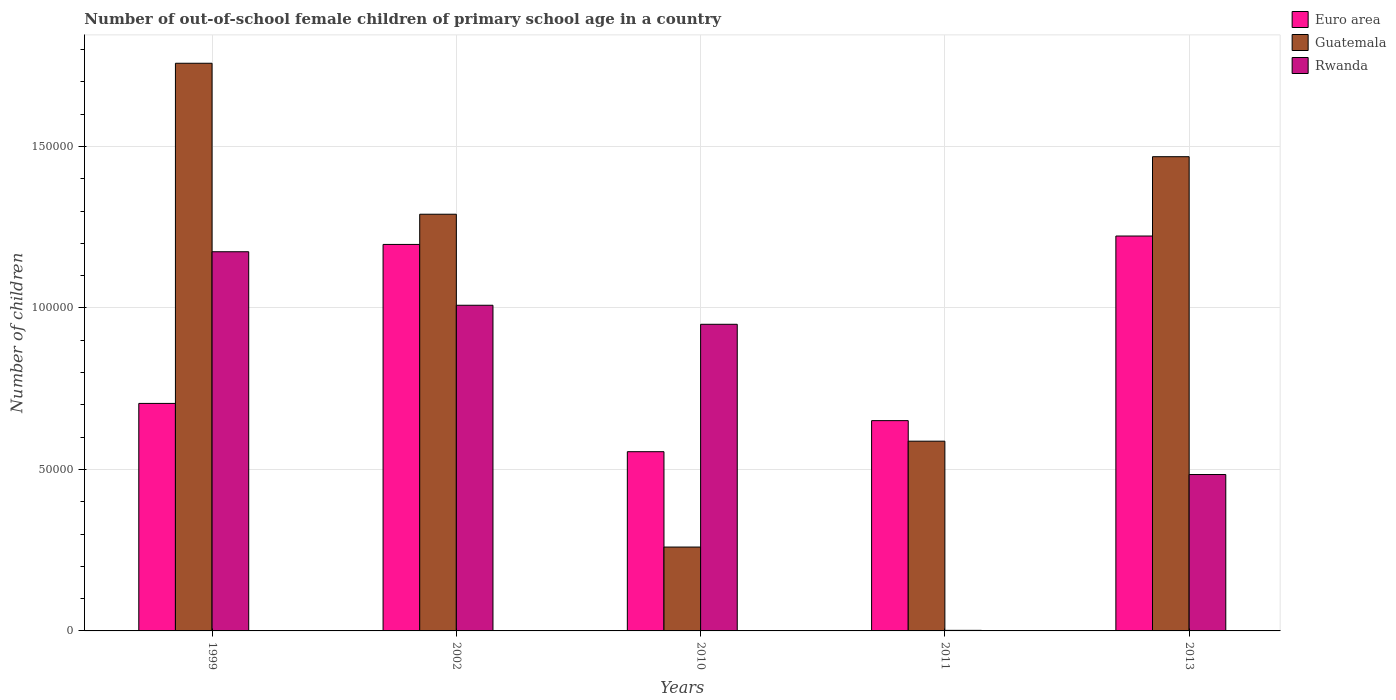How many different coloured bars are there?
Provide a succinct answer. 3. How many bars are there on the 2nd tick from the right?
Give a very brief answer. 3. What is the number of out-of-school female children in Rwanda in 1999?
Your answer should be compact. 1.17e+05. Across all years, what is the maximum number of out-of-school female children in Rwanda?
Keep it short and to the point. 1.17e+05. Across all years, what is the minimum number of out-of-school female children in Euro area?
Provide a succinct answer. 5.55e+04. What is the total number of out-of-school female children in Guatemala in the graph?
Keep it short and to the point. 5.36e+05. What is the difference between the number of out-of-school female children in Rwanda in 2010 and that in 2011?
Provide a short and direct response. 9.48e+04. What is the difference between the number of out-of-school female children in Guatemala in 2010 and the number of out-of-school female children in Euro area in 1999?
Ensure brevity in your answer.  -4.45e+04. What is the average number of out-of-school female children in Guatemala per year?
Your answer should be compact. 1.07e+05. In the year 2013, what is the difference between the number of out-of-school female children in Guatemala and number of out-of-school female children in Rwanda?
Provide a short and direct response. 9.84e+04. What is the ratio of the number of out-of-school female children in Rwanda in 2002 to that in 2013?
Provide a succinct answer. 2.08. Is the number of out-of-school female children in Guatemala in 1999 less than that in 2013?
Your answer should be very brief. No. Is the difference between the number of out-of-school female children in Guatemala in 1999 and 2010 greater than the difference between the number of out-of-school female children in Rwanda in 1999 and 2010?
Make the answer very short. Yes. What is the difference between the highest and the second highest number of out-of-school female children in Guatemala?
Your response must be concise. 2.89e+04. What is the difference between the highest and the lowest number of out-of-school female children in Guatemala?
Offer a terse response. 1.50e+05. What does the 2nd bar from the left in 2011 represents?
Provide a short and direct response. Guatemala. What does the 1st bar from the right in 1999 represents?
Provide a succinct answer. Rwanda. How many bars are there?
Provide a short and direct response. 15. Are all the bars in the graph horizontal?
Ensure brevity in your answer.  No. What is the difference between two consecutive major ticks on the Y-axis?
Give a very brief answer. 5.00e+04. Are the values on the major ticks of Y-axis written in scientific E-notation?
Offer a terse response. No. Does the graph contain any zero values?
Make the answer very short. No. Does the graph contain grids?
Your answer should be very brief. Yes. What is the title of the graph?
Offer a terse response. Number of out-of-school female children of primary school age in a country. Does "Gabon" appear as one of the legend labels in the graph?
Offer a terse response. No. What is the label or title of the X-axis?
Keep it short and to the point. Years. What is the label or title of the Y-axis?
Make the answer very short. Number of children. What is the Number of children of Euro area in 1999?
Ensure brevity in your answer.  7.04e+04. What is the Number of children of Guatemala in 1999?
Provide a short and direct response. 1.76e+05. What is the Number of children of Rwanda in 1999?
Provide a short and direct response. 1.17e+05. What is the Number of children of Euro area in 2002?
Offer a very short reply. 1.20e+05. What is the Number of children in Guatemala in 2002?
Keep it short and to the point. 1.29e+05. What is the Number of children in Rwanda in 2002?
Your response must be concise. 1.01e+05. What is the Number of children of Euro area in 2010?
Give a very brief answer. 5.55e+04. What is the Number of children in Guatemala in 2010?
Give a very brief answer. 2.60e+04. What is the Number of children in Rwanda in 2010?
Ensure brevity in your answer.  9.49e+04. What is the Number of children of Euro area in 2011?
Your answer should be compact. 6.51e+04. What is the Number of children of Guatemala in 2011?
Offer a very short reply. 5.87e+04. What is the Number of children of Rwanda in 2011?
Provide a succinct answer. 176. What is the Number of children of Euro area in 2013?
Make the answer very short. 1.22e+05. What is the Number of children of Guatemala in 2013?
Your response must be concise. 1.47e+05. What is the Number of children in Rwanda in 2013?
Your response must be concise. 4.84e+04. Across all years, what is the maximum Number of children of Euro area?
Provide a short and direct response. 1.22e+05. Across all years, what is the maximum Number of children in Guatemala?
Give a very brief answer. 1.76e+05. Across all years, what is the maximum Number of children in Rwanda?
Provide a succinct answer. 1.17e+05. Across all years, what is the minimum Number of children of Euro area?
Ensure brevity in your answer.  5.55e+04. Across all years, what is the minimum Number of children of Guatemala?
Provide a succinct answer. 2.60e+04. Across all years, what is the minimum Number of children of Rwanda?
Offer a very short reply. 176. What is the total Number of children of Euro area in the graph?
Your answer should be compact. 4.33e+05. What is the total Number of children in Guatemala in the graph?
Give a very brief answer. 5.36e+05. What is the total Number of children of Rwanda in the graph?
Offer a terse response. 3.62e+05. What is the difference between the Number of children of Euro area in 1999 and that in 2002?
Your answer should be compact. -4.92e+04. What is the difference between the Number of children in Guatemala in 1999 and that in 2002?
Your answer should be compact. 4.67e+04. What is the difference between the Number of children in Rwanda in 1999 and that in 2002?
Your answer should be very brief. 1.66e+04. What is the difference between the Number of children of Euro area in 1999 and that in 2010?
Keep it short and to the point. 1.49e+04. What is the difference between the Number of children of Guatemala in 1999 and that in 2010?
Provide a succinct answer. 1.50e+05. What is the difference between the Number of children in Rwanda in 1999 and that in 2010?
Provide a short and direct response. 2.25e+04. What is the difference between the Number of children of Euro area in 1999 and that in 2011?
Make the answer very short. 5330. What is the difference between the Number of children in Guatemala in 1999 and that in 2011?
Keep it short and to the point. 1.17e+05. What is the difference between the Number of children in Rwanda in 1999 and that in 2011?
Offer a very short reply. 1.17e+05. What is the difference between the Number of children in Euro area in 1999 and that in 2013?
Provide a succinct answer. -5.18e+04. What is the difference between the Number of children in Guatemala in 1999 and that in 2013?
Ensure brevity in your answer.  2.89e+04. What is the difference between the Number of children of Rwanda in 1999 and that in 2013?
Keep it short and to the point. 6.90e+04. What is the difference between the Number of children of Euro area in 2002 and that in 2010?
Offer a very short reply. 6.42e+04. What is the difference between the Number of children in Guatemala in 2002 and that in 2010?
Ensure brevity in your answer.  1.03e+05. What is the difference between the Number of children in Rwanda in 2002 and that in 2010?
Provide a short and direct response. 5894. What is the difference between the Number of children in Euro area in 2002 and that in 2011?
Provide a short and direct response. 5.46e+04. What is the difference between the Number of children in Guatemala in 2002 and that in 2011?
Your answer should be compact. 7.03e+04. What is the difference between the Number of children in Rwanda in 2002 and that in 2011?
Give a very brief answer. 1.01e+05. What is the difference between the Number of children in Euro area in 2002 and that in 2013?
Make the answer very short. -2605. What is the difference between the Number of children of Guatemala in 2002 and that in 2013?
Your response must be concise. -1.78e+04. What is the difference between the Number of children in Rwanda in 2002 and that in 2013?
Make the answer very short. 5.24e+04. What is the difference between the Number of children of Euro area in 2010 and that in 2011?
Your response must be concise. -9619. What is the difference between the Number of children in Guatemala in 2010 and that in 2011?
Give a very brief answer. -3.28e+04. What is the difference between the Number of children in Rwanda in 2010 and that in 2011?
Keep it short and to the point. 9.48e+04. What is the difference between the Number of children of Euro area in 2010 and that in 2013?
Ensure brevity in your answer.  -6.68e+04. What is the difference between the Number of children of Guatemala in 2010 and that in 2013?
Your answer should be very brief. -1.21e+05. What is the difference between the Number of children of Rwanda in 2010 and that in 2013?
Provide a succinct answer. 4.65e+04. What is the difference between the Number of children in Euro area in 2011 and that in 2013?
Ensure brevity in your answer.  -5.72e+04. What is the difference between the Number of children in Guatemala in 2011 and that in 2013?
Make the answer very short. -8.81e+04. What is the difference between the Number of children in Rwanda in 2011 and that in 2013?
Provide a succinct answer. -4.83e+04. What is the difference between the Number of children in Euro area in 1999 and the Number of children in Guatemala in 2002?
Provide a succinct answer. -5.86e+04. What is the difference between the Number of children in Euro area in 1999 and the Number of children in Rwanda in 2002?
Give a very brief answer. -3.04e+04. What is the difference between the Number of children of Guatemala in 1999 and the Number of children of Rwanda in 2002?
Your answer should be very brief. 7.49e+04. What is the difference between the Number of children in Euro area in 1999 and the Number of children in Guatemala in 2010?
Your answer should be very brief. 4.45e+04. What is the difference between the Number of children of Euro area in 1999 and the Number of children of Rwanda in 2010?
Your answer should be compact. -2.45e+04. What is the difference between the Number of children of Guatemala in 1999 and the Number of children of Rwanda in 2010?
Your response must be concise. 8.08e+04. What is the difference between the Number of children of Euro area in 1999 and the Number of children of Guatemala in 2011?
Your response must be concise. 1.17e+04. What is the difference between the Number of children of Euro area in 1999 and the Number of children of Rwanda in 2011?
Offer a terse response. 7.03e+04. What is the difference between the Number of children of Guatemala in 1999 and the Number of children of Rwanda in 2011?
Make the answer very short. 1.76e+05. What is the difference between the Number of children in Euro area in 1999 and the Number of children in Guatemala in 2013?
Your answer should be compact. -7.64e+04. What is the difference between the Number of children of Euro area in 1999 and the Number of children of Rwanda in 2013?
Provide a short and direct response. 2.20e+04. What is the difference between the Number of children of Guatemala in 1999 and the Number of children of Rwanda in 2013?
Provide a succinct answer. 1.27e+05. What is the difference between the Number of children in Euro area in 2002 and the Number of children in Guatemala in 2010?
Make the answer very short. 9.37e+04. What is the difference between the Number of children in Euro area in 2002 and the Number of children in Rwanda in 2010?
Your response must be concise. 2.47e+04. What is the difference between the Number of children in Guatemala in 2002 and the Number of children in Rwanda in 2010?
Your response must be concise. 3.41e+04. What is the difference between the Number of children of Euro area in 2002 and the Number of children of Guatemala in 2011?
Provide a short and direct response. 6.09e+04. What is the difference between the Number of children of Euro area in 2002 and the Number of children of Rwanda in 2011?
Make the answer very short. 1.19e+05. What is the difference between the Number of children in Guatemala in 2002 and the Number of children in Rwanda in 2011?
Your response must be concise. 1.29e+05. What is the difference between the Number of children of Euro area in 2002 and the Number of children of Guatemala in 2013?
Your answer should be compact. -2.72e+04. What is the difference between the Number of children of Euro area in 2002 and the Number of children of Rwanda in 2013?
Make the answer very short. 7.12e+04. What is the difference between the Number of children of Guatemala in 2002 and the Number of children of Rwanda in 2013?
Keep it short and to the point. 8.06e+04. What is the difference between the Number of children in Euro area in 2010 and the Number of children in Guatemala in 2011?
Your answer should be compact. -3255. What is the difference between the Number of children in Euro area in 2010 and the Number of children in Rwanda in 2011?
Your answer should be very brief. 5.53e+04. What is the difference between the Number of children of Guatemala in 2010 and the Number of children of Rwanda in 2011?
Make the answer very short. 2.58e+04. What is the difference between the Number of children in Euro area in 2010 and the Number of children in Guatemala in 2013?
Ensure brevity in your answer.  -9.13e+04. What is the difference between the Number of children of Euro area in 2010 and the Number of children of Rwanda in 2013?
Your response must be concise. 7066. What is the difference between the Number of children in Guatemala in 2010 and the Number of children in Rwanda in 2013?
Make the answer very short. -2.25e+04. What is the difference between the Number of children of Euro area in 2011 and the Number of children of Guatemala in 2013?
Ensure brevity in your answer.  -8.17e+04. What is the difference between the Number of children of Euro area in 2011 and the Number of children of Rwanda in 2013?
Your answer should be very brief. 1.67e+04. What is the difference between the Number of children of Guatemala in 2011 and the Number of children of Rwanda in 2013?
Make the answer very short. 1.03e+04. What is the average Number of children of Euro area per year?
Keep it short and to the point. 8.66e+04. What is the average Number of children in Guatemala per year?
Offer a very short reply. 1.07e+05. What is the average Number of children of Rwanda per year?
Provide a short and direct response. 7.24e+04. In the year 1999, what is the difference between the Number of children in Euro area and Number of children in Guatemala?
Your response must be concise. -1.05e+05. In the year 1999, what is the difference between the Number of children in Euro area and Number of children in Rwanda?
Make the answer very short. -4.70e+04. In the year 1999, what is the difference between the Number of children of Guatemala and Number of children of Rwanda?
Offer a very short reply. 5.84e+04. In the year 2002, what is the difference between the Number of children in Euro area and Number of children in Guatemala?
Give a very brief answer. -9356. In the year 2002, what is the difference between the Number of children in Euro area and Number of children in Rwanda?
Make the answer very short. 1.88e+04. In the year 2002, what is the difference between the Number of children in Guatemala and Number of children in Rwanda?
Provide a short and direct response. 2.82e+04. In the year 2010, what is the difference between the Number of children in Euro area and Number of children in Guatemala?
Ensure brevity in your answer.  2.95e+04. In the year 2010, what is the difference between the Number of children of Euro area and Number of children of Rwanda?
Make the answer very short. -3.94e+04. In the year 2010, what is the difference between the Number of children in Guatemala and Number of children in Rwanda?
Keep it short and to the point. -6.90e+04. In the year 2011, what is the difference between the Number of children of Euro area and Number of children of Guatemala?
Offer a very short reply. 6364. In the year 2011, what is the difference between the Number of children of Euro area and Number of children of Rwanda?
Offer a terse response. 6.49e+04. In the year 2011, what is the difference between the Number of children in Guatemala and Number of children in Rwanda?
Offer a very short reply. 5.86e+04. In the year 2013, what is the difference between the Number of children in Euro area and Number of children in Guatemala?
Give a very brief answer. -2.46e+04. In the year 2013, what is the difference between the Number of children in Euro area and Number of children in Rwanda?
Your response must be concise. 7.38e+04. In the year 2013, what is the difference between the Number of children of Guatemala and Number of children of Rwanda?
Offer a terse response. 9.84e+04. What is the ratio of the Number of children of Euro area in 1999 to that in 2002?
Keep it short and to the point. 0.59. What is the ratio of the Number of children in Guatemala in 1999 to that in 2002?
Make the answer very short. 1.36. What is the ratio of the Number of children in Rwanda in 1999 to that in 2002?
Provide a short and direct response. 1.16. What is the ratio of the Number of children in Euro area in 1999 to that in 2010?
Make the answer very short. 1.27. What is the ratio of the Number of children in Guatemala in 1999 to that in 2010?
Ensure brevity in your answer.  6.77. What is the ratio of the Number of children of Rwanda in 1999 to that in 2010?
Give a very brief answer. 1.24. What is the ratio of the Number of children in Euro area in 1999 to that in 2011?
Offer a terse response. 1.08. What is the ratio of the Number of children in Guatemala in 1999 to that in 2011?
Keep it short and to the point. 2.99. What is the ratio of the Number of children of Rwanda in 1999 to that in 2011?
Ensure brevity in your answer.  667.09. What is the ratio of the Number of children in Euro area in 1999 to that in 2013?
Your answer should be compact. 0.58. What is the ratio of the Number of children in Guatemala in 1999 to that in 2013?
Make the answer very short. 1.2. What is the ratio of the Number of children in Rwanda in 1999 to that in 2013?
Keep it short and to the point. 2.42. What is the ratio of the Number of children in Euro area in 2002 to that in 2010?
Keep it short and to the point. 2.16. What is the ratio of the Number of children in Guatemala in 2002 to that in 2010?
Provide a short and direct response. 4.97. What is the ratio of the Number of children in Rwanda in 2002 to that in 2010?
Your answer should be compact. 1.06. What is the ratio of the Number of children of Euro area in 2002 to that in 2011?
Keep it short and to the point. 1.84. What is the ratio of the Number of children of Guatemala in 2002 to that in 2011?
Keep it short and to the point. 2.2. What is the ratio of the Number of children in Rwanda in 2002 to that in 2011?
Offer a very short reply. 572.94. What is the ratio of the Number of children in Euro area in 2002 to that in 2013?
Your answer should be compact. 0.98. What is the ratio of the Number of children of Guatemala in 2002 to that in 2013?
Ensure brevity in your answer.  0.88. What is the ratio of the Number of children of Rwanda in 2002 to that in 2013?
Ensure brevity in your answer.  2.08. What is the ratio of the Number of children in Euro area in 2010 to that in 2011?
Keep it short and to the point. 0.85. What is the ratio of the Number of children in Guatemala in 2010 to that in 2011?
Keep it short and to the point. 0.44. What is the ratio of the Number of children of Rwanda in 2010 to that in 2011?
Keep it short and to the point. 539.45. What is the ratio of the Number of children in Euro area in 2010 to that in 2013?
Offer a terse response. 0.45. What is the ratio of the Number of children of Guatemala in 2010 to that in 2013?
Ensure brevity in your answer.  0.18. What is the ratio of the Number of children in Rwanda in 2010 to that in 2013?
Your answer should be compact. 1.96. What is the ratio of the Number of children in Euro area in 2011 to that in 2013?
Give a very brief answer. 0.53. What is the ratio of the Number of children of Guatemala in 2011 to that in 2013?
Make the answer very short. 0.4. What is the ratio of the Number of children in Rwanda in 2011 to that in 2013?
Your answer should be very brief. 0. What is the difference between the highest and the second highest Number of children in Euro area?
Make the answer very short. 2605. What is the difference between the highest and the second highest Number of children of Guatemala?
Ensure brevity in your answer.  2.89e+04. What is the difference between the highest and the second highest Number of children of Rwanda?
Provide a succinct answer. 1.66e+04. What is the difference between the highest and the lowest Number of children of Euro area?
Make the answer very short. 6.68e+04. What is the difference between the highest and the lowest Number of children of Guatemala?
Give a very brief answer. 1.50e+05. What is the difference between the highest and the lowest Number of children in Rwanda?
Make the answer very short. 1.17e+05. 